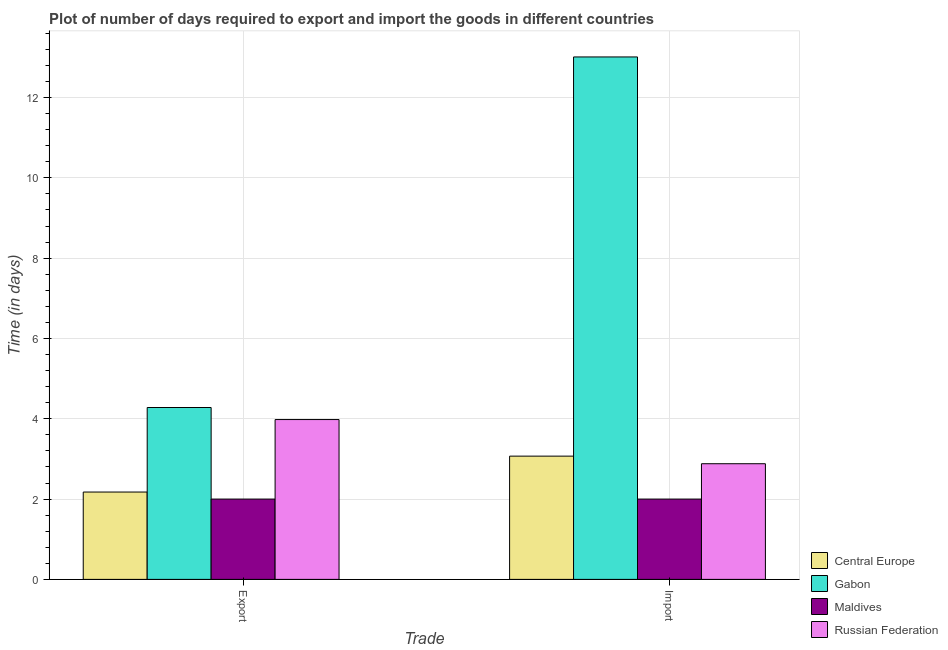How many different coloured bars are there?
Ensure brevity in your answer.  4. Are the number of bars per tick equal to the number of legend labels?
Give a very brief answer. Yes. How many bars are there on the 1st tick from the left?
Your answer should be very brief. 4. How many bars are there on the 1st tick from the right?
Provide a succinct answer. 4. What is the label of the 1st group of bars from the left?
Keep it short and to the point. Export. What is the time required to export in Central Europe?
Your answer should be very brief. 2.17. Across all countries, what is the maximum time required to export?
Offer a very short reply. 4.28. In which country was the time required to export maximum?
Ensure brevity in your answer.  Gabon. In which country was the time required to export minimum?
Your answer should be very brief. Maldives. What is the total time required to import in the graph?
Keep it short and to the point. 20.96. What is the difference between the time required to export in Maldives and that in Russian Federation?
Your answer should be very brief. -1.98. What is the difference between the time required to export in Russian Federation and the time required to import in Maldives?
Offer a terse response. 1.98. What is the average time required to import per country?
Ensure brevity in your answer.  5.24. What is the difference between the time required to export and time required to import in Maldives?
Provide a succinct answer. 0. In how many countries, is the time required to export greater than 11.2 days?
Ensure brevity in your answer.  0. What is the ratio of the time required to export in Central Europe to that in Gabon?
Your answer should be very brief. 0.51. Is the time required to import in Central Europe less than that in Russian Federation?
Offer a very short reply. No. What does the 1st bar from the left in Export represents?
Keep it short and to the point. Central Europe. What does the 1st bar from the right in Export represents?
Your answer should be compact. Russian Federation. How many bars are there?
Give a very brief answer. 8. Are all the bars in the graph horizontal?
Offer a very short reply. No. How many countries are there in the graph?
Offer a very short reply. 4. Are the values on the major ticks of Y-axis written in scientific E-notation?
Offer a terse response. No. How many legend labels are there?
Provide a short and direct response. 4. What is the title of the graph?
Provide a short and direct response. Plot of number of days required to export and import the goods in different countries. What is the label or title of the X-axis?
Provide a short and direct response. Trade. What is the label or title of the Y-axis?
Give a very brief answer. Time (in days). What is the Time (in days) of Central Europe in Export?
Keep it short and to the point. 2.17. What is the Time (in days) of Gabon in Export?
Ensure brevity in your answer.  4.28. What is the Time (in days) in Maldives in Export?
Make the answer very short. 2. What is the Time (in days) of Russian Federation in Export?
Your answer should be compact. 3.98. What is the Time (in days) of Central Europe in Import?
Offer a terse response. 3.07. What is the Time (in days) of Gabon in Import?
Your answer should be compact. 13.01. What is the Time (in days) in Russian Federation in Import?
Make the answer very short. 2.88. Across all Trade, what is the maximum Time (in days) of Central Europe?
Offer a terse response. 3.07. Across all Trade, what is the maximum Time (in days) of Gabon?
Provide a succinct answer. 13.01. Across all Trade, what is the maximum Time (in days) in Maldives?
Your answer should be compact. 2. Across all Trade, what is the maximum Time (in days) of Russian Federation?
Give a very brief answer. 3.98. Across all Trade, what is the minimum Time (in days) in Central Europe?
Give a very brief answer. 2.17. Across all Trade, what is the minimum Time (in days) in Gabon?
Make the answer very short. 4.28. Across all Trade, what is the minimum Time (in days) of Russian Federation?
Make the answer very short. 2.88. What is the total Time (in days) in Central Europe in the graph?
Ensure brevity in your answer.  5.24. What is the total Time (in days) of Gabon in the graph?
Your answer should be compact. 17.29. What is the total Time (in days) in Russian Federation in the graph?
Your response must be concise. 6.86. What is the difference between the Time (in days) of Central Europe in Export and that in Import?
Make the answer very short. -0.89. What is the difference between the Time (in days) of Gabon in Export and that in Import?
Ensure brevity in your answer.  -8.73. What is the difference between the Time (in days) of Russian Federation in Export and that in Import?
Provide a short and direct response. 1.1. What is the difference between the Time (in days) in Central Europe in Export and the Time (in days) in Gabon in Import?
Keep it short and to the point. -10.84. What is the difference between the Time (in days) of Central Europe in Export and the Time (in days) of Maldives in Import?
Your response must be concise. 0.17. What is the difference between the Time (in days) in Central Europe in Export and the Time (in days) in Russian Federation in Import?
Provide a succinct answer. -0.7. What is the difference between the Time (in days) in Gabon in Export and the Time (in days) in Maldives in Import?
Make the answer very short. 2.28. What is the difference between the Time (in days) of Maldives in Export and the Time (in days) of Russian Federation in Import?
Offer a terse response. -0.88. What is the average Time (in days) in Central Europe per Trade?
Keep it short and to the point. 2.62. What is the average Time (in days) in Gabon per Trade?
Make the answer very short. 8.64. What is the average Time (in days) of Russian Federation per Trade?
Offer a very short reply. 3.43. What is the difference between the Time (in days) of Central Europe and Time (in days) of Gabon in Export?
Provide a short and direct response. -2.1. What is the difference between the Time (in days) of Central Europe and Time (in days) of Maldives in Export?
Your response must be concise. 0.17. What is the difference between the Time (in days) in Central Europe and Time (in days) in Russian Federation in Export?
Ensure brevity in your answer.  -1.8. What is the difference between the Time (in days) of Gabon and Time (in days) of Maldives in Export?
Provide a succinct answer. 2.28. What is the difference between the Time (in days) of Gabon and Time (in days) of Russian Federation in Export?
Provide a short and direct response. 0.3. What is the difference between the Time (in days) in Maldives and Time (in days) in Russian Federation in Export?
Keep it short and to the point. -1.98. What is the difference between the Time (in days) in Central Europe and Time (in days) in Gabon in Import?
Your response must be concise. -9.94. What is the difference between the Time (in days) of Central Europe and Time (in days) of Maldives in Import?
Ensure brevity in your answer.  1.07. What is the difference between the Time (in days) of Central Europe and Time (in days) of Russian Federation in Import?
Your answer should be very brief. 0.19. What is the difference between the Time (in days) of Gabon and Time (in days) of Maldives in Import?
Make the answer very short. 11.01. What is the difference between the Time (in days) of Gabon and Time (in days) of Russian Federation in Import?
Provide a short and direct response. 10.13. What is the difference between the Time (in days) in Maldives and Time (in days) in Russian Federation in Import?
Your answer should be very brief. -0.88. What is the ratio of the Time (in days) in Central Europe in Export to that in Import?
Offer a very short reply. 0.71. What is the ratio of the Time (in days) of Gabon in Export to that in Import?
Provide a short and direct response. 0.33. What is the ratio of the Time (in days) in Russian Federation in Export to that in Import?
Give a very brief answer. 1.38. What is the difference between the highest and the second highest Time (in days) of Central Europe?
Offer a terse response. 0.89. What is the difference between the highest and the second highest Time (in days) of Gabon?
Provide a succinct answer. 8.73. What is the difference between the highest and the second highest Time (in days) of Maldives?
Make the answer very short. 0. What is the difference between the highest and the lowest Time (in days) in Central Europe?
Offer a very short reply. 0.89. What is the difference between the highest and the lowest Time (in days) of Gabon?
Offer a very short reply. 8.73. What is the difference between the highest and the lowest Time (in days) of Russian Federation?
Give a very brief answer. 1.1. 